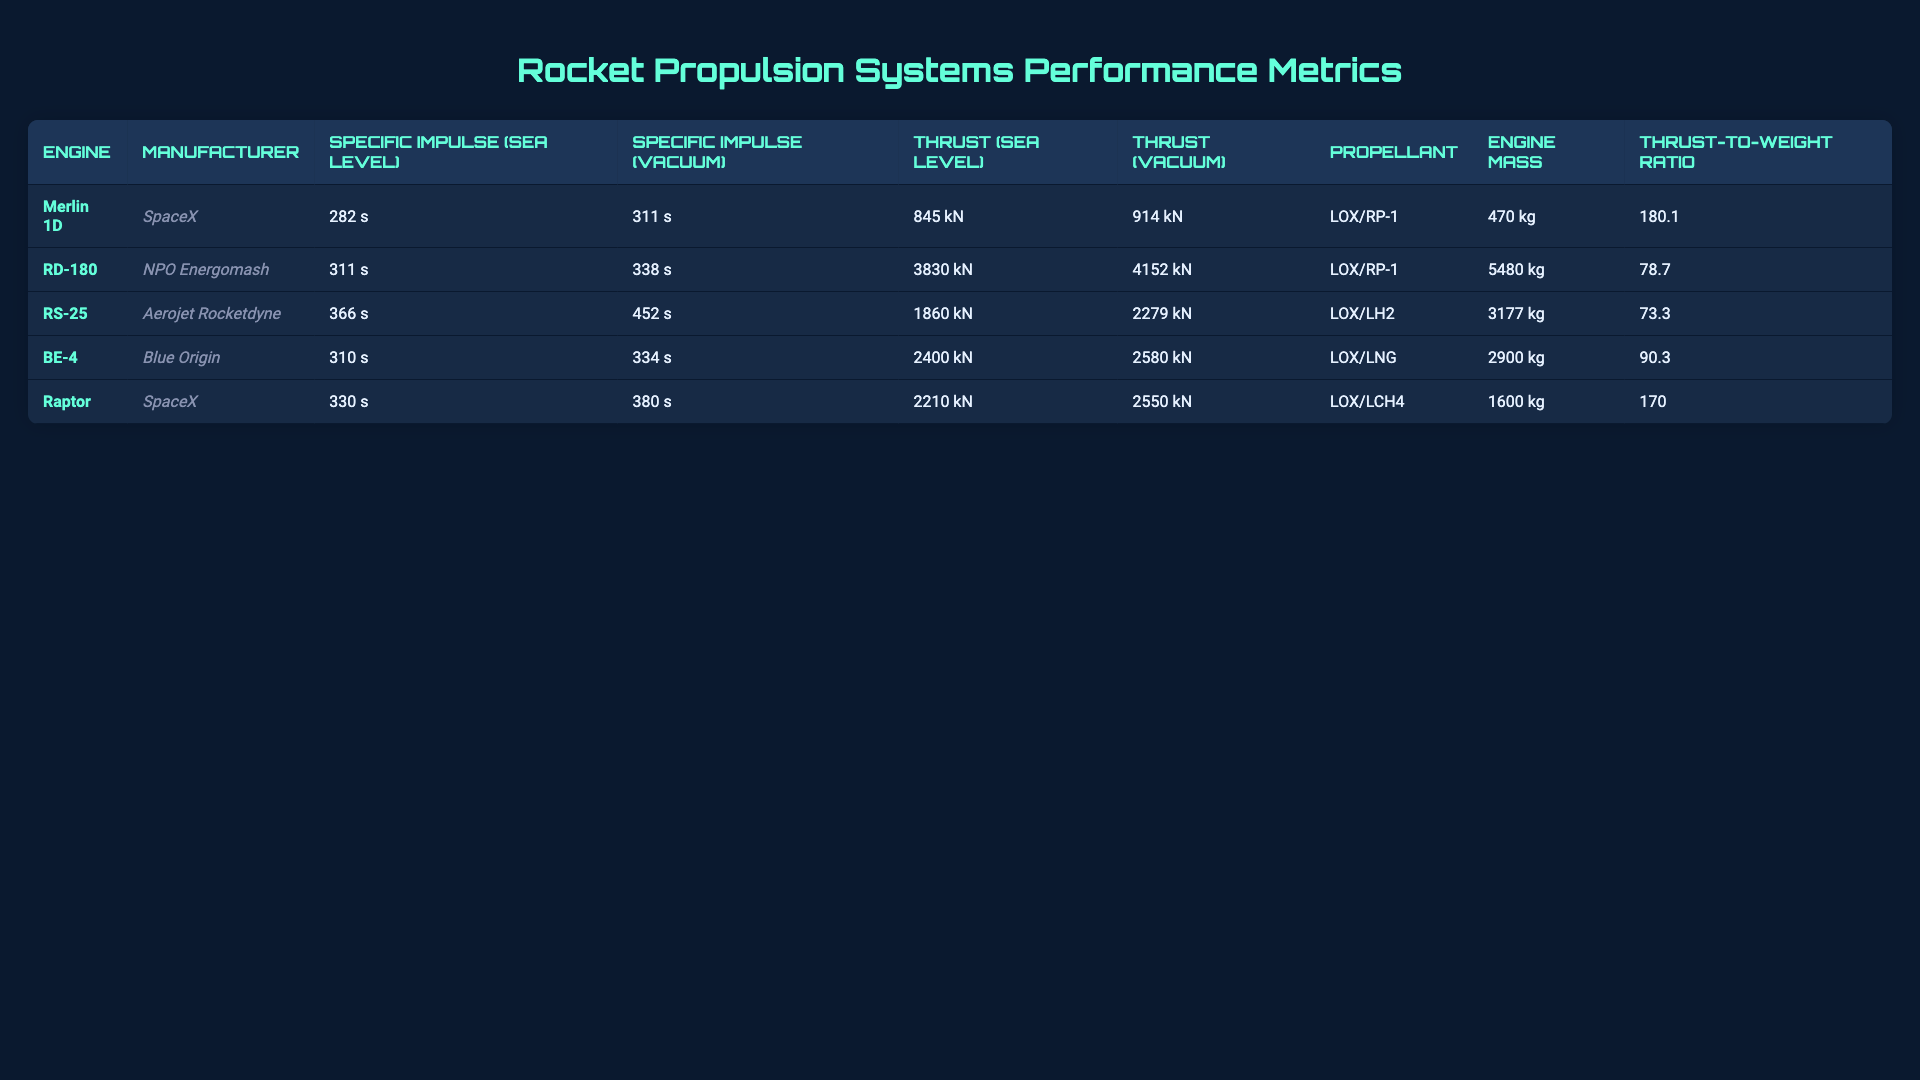What is the specific impulse of the RD-180 at sea level? The specific impulse of the RD-180 at sea level is listed in the table under "Specific Impulse (Sea Level)", which shows a value of 311 seconds.
Answer: 311 s Which engine has the highest thrust at vacuum? The engine with the highest thrust at vacuum is identified by looking at the "Thrust (Vacuum)" column. The RD-180 has the highest value of 4152 kN.
Answer: 4152 kN What propellant is used in the RS-25 engine? The propellant used in the RS-25 engine is provided in the "Propellant" column, which states that it uses LOX/LH2.
Answer: LOX/LH2 Calculate the average thrust at sea level of all propulsion systems. To find the average thrust at sea level, sum the thrust values: 845 + 3830 + 1860 + 2400 + 2210 = 11145 kN. There are 5 engines, so the average is 11145/5 = 2229 kN.
Answer: 2229 kN Does the Raptor engine have a higher thrust-to-weight ratio than the RD-180? The thrust-to-weight ratio of the Raptor is compared to that of the RD-180 by finding the values in the "Thrust-to-Weight Ratio" column. Raptor has 170, while RD-180 has 78.7, thus it is indeed higher.
Answer: Yes Which engine has the lowest specific impulse at sea level? To identify the lowest specific impulse at sea level, we check the "Specific Impulse (Sea Level)" column for the minimum value. The Merlin 1D has the lowest value of 282 seconds.
Answer: 282 s What is the difference in thrust (vacuum) between the Raptor and BE-4 engines? From the "Thrust (Vacuum)" column, the Raptor has 2550 kN and the BE-4 has 2580 kN. The difference is calculated as 2580 - 2550 = 30 kN.
Answer: 30 kN Which manufacturer produces the engine with the lightest mass? To find the lightest engine mass, we review the "Engine Mass" column. The Merlin 1D has a mass of 470 kg, which is the lightest compared to others.
Answer: SpaceX Is the specific impulse of the BE-4 higher than that of the Merlin 1D at sea level? Comparing the specific impulses in the "Specific Impulse (Sea Level)" column, BE-4 has 310 seconds and Merlin 1D has 282 seconds, which shows BE-4 is indeed higher.
Answer: Yes What is the relationship between specific impulse and thrust for the RD-180 engine? By analyzing the specific impulse values (311 s at sea level and 338 s in vacuum) and thrust (3830 kN at sea level and 4152 kN in vacuum), we see that as specific impulse increases, thrust also increases, indicating a positive relationship.
Answer: Positive relationship 